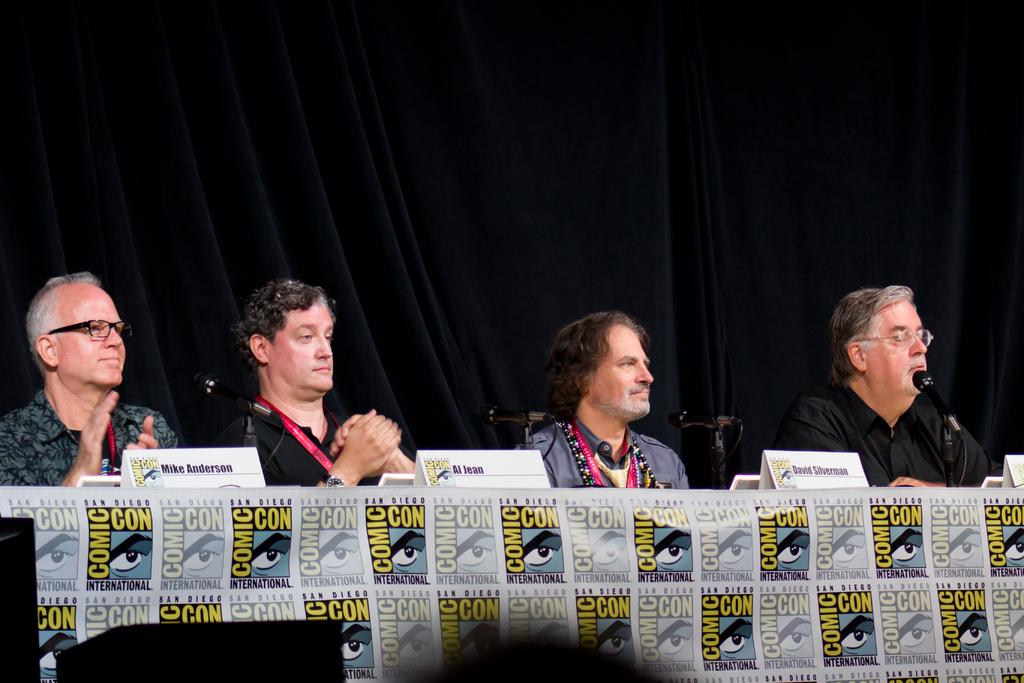How many people are in the image? There is a group of people in the image. What are the people doing in the image? The people are sitting on chairs. What is on the table in the image? There is a table in the image with name boards and microphones on it. What color is the background in the image? The background of the image is black. How many farmers are present in the image? There is no mention of farmers in the image; it features a group of people sitting on chairs with a table and related items. 